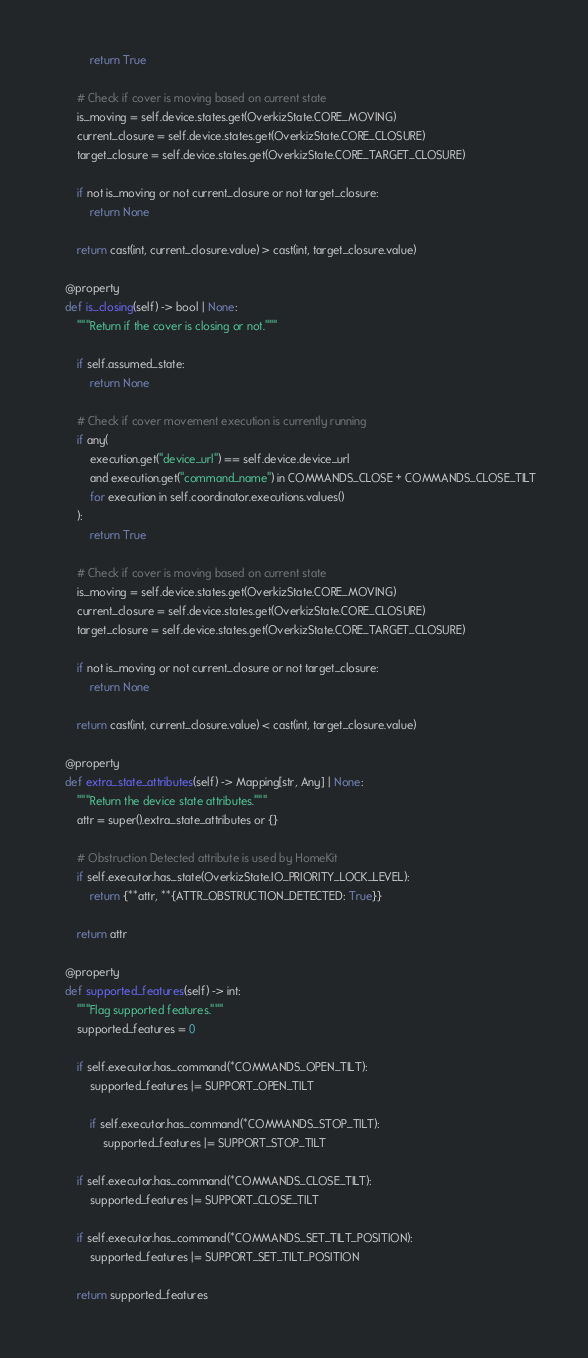Convert code to text. <code><loc_0><loc_0><loc_500><loc_500><_Python_>            return True

        # Check if cover is moving based on current state
        is_moving = self.device.states.get(OverkizState.CORE_MOVING)
        current_closure = self.device.states.get(OverkizState.CORE_CLOSURE)
        target_closure = self.device.states.get(OverkizState.CORE_TARGET_CLOSURE)

        if not is_moving or not current_closure or not target_closure:
            return None

        return cast(int, current_closure.value) > cast(int, target_closure.value)

    @property
    def is_closing(self) -> bool | None:
        """Return if the cover is closing or not."""

        if self.assumed_state:
            return None

        # Check if cover movement execution is currently running
        if any(
            execution.get("device_url") == self.device.device_url
            and execution.get("command_name") in COMMANDS_CLOSE + COMMANDS_CLOSE_TILT
            for execution in self.coordinator.executions.values()
        ):
            return True

        # Check if cover is moving based on current state
        is_moving = self.device.states.get(OverkizState.CORE_MOVING)
        current_closure = self.device.states.get(OverkizState.CORE_CLOSURE)
        target_closure = self.device.states.get(OverkizState.CORE_TARGET_CLOSURE)

        if not is_moving or not current_closure or not target_closure:
            return None

        return cast(int, current_closure.value) < cast(int, target_closure.value)

    @property
    def extra_state_attributes(self) -> Mapping[str, Any] | None:
        """Return the device state attributes."""
        attr = super().extra_state_attributes or {}

        # Obstruction Detected attribute is used by HomeKit
        if self.executor.has_state(OverkizState.IO_PRIORITY_LOCK_LEVEL):
            return {**attr, **{ATTR_OBSTRUCTION_DETECTED: True}}

        return attr

    @property
    def supported_features(self) -> int:
        """Flag supported features."""
        supported_features = 0

        if self.executor.has_command(*COMMANDS_OPEN_TILT):
            supported_features |= SUPPORT_OPEN_TILT

            if self.executor.has_command(*COMMANDS_STOP_TILT):
                supported_features |= SUPPORT_STOP_TILT

        if self.executor.has_command(*COMMANDS_CLOSE_TILT):
            supported_features |= SUPPORT_CLOSE_TILT

        if self.executor.has_command(*COMMANDS_SET_TILT_POSITION):
            supported_features |= SUPPORT_SET_TILT_POSITION

        return supported_features
</code> 